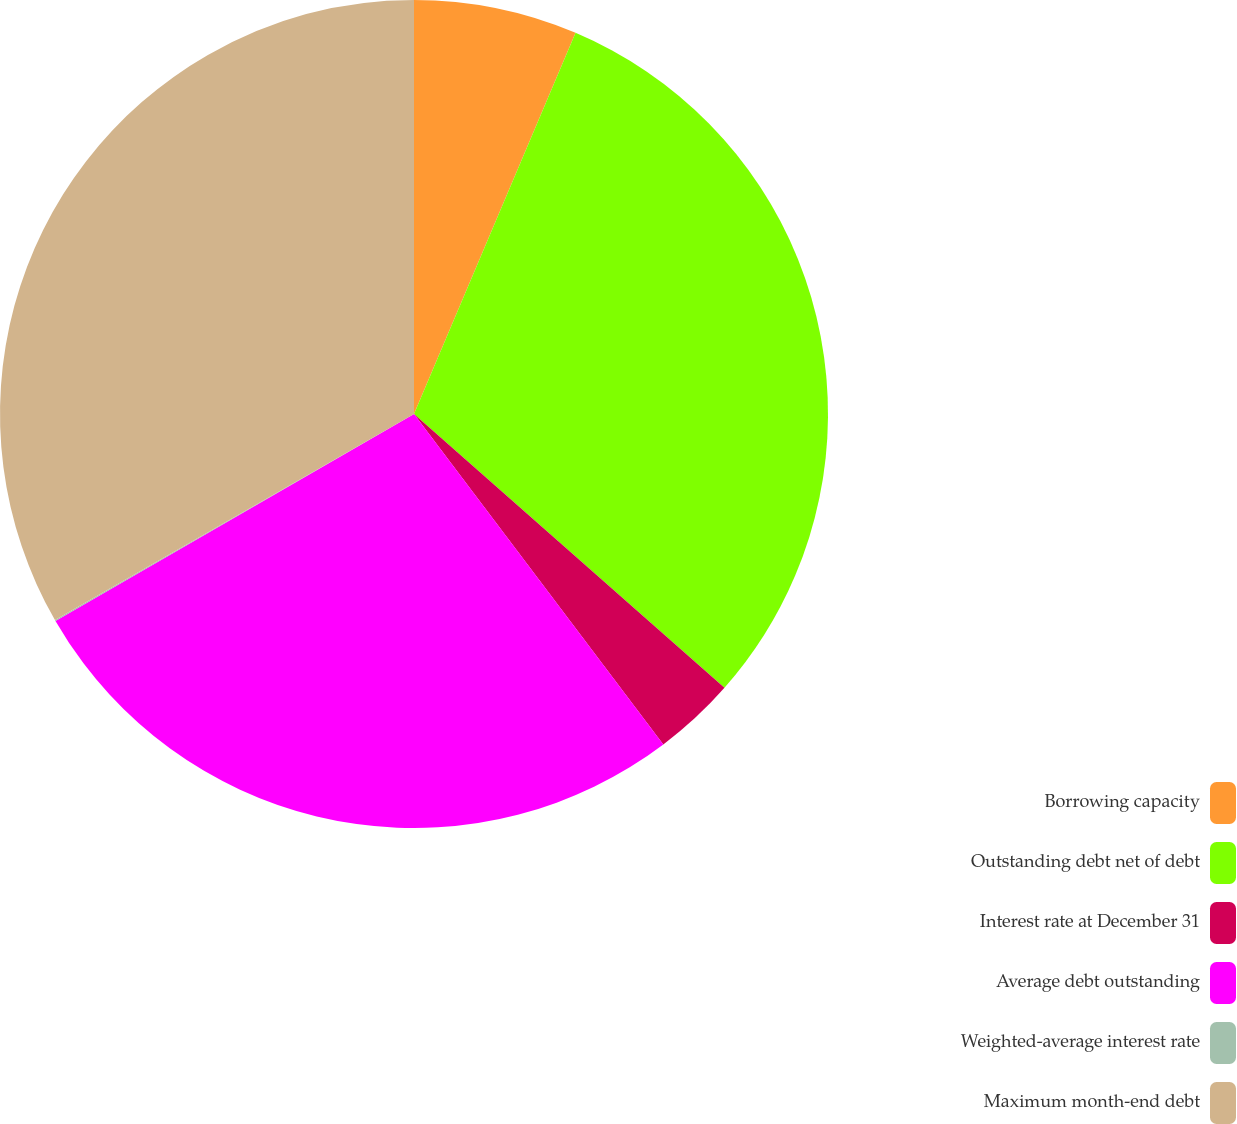Convert chart to OTSL. <chart><loc_0><loc_0><loc_500><loc_500><pie_chart><fcel>Borrowing capacity<fcel>Outstanding debt net of debt<fcel>Interest rate at December 31<fcel>Average debt outstanding<fcel>Weighted-average interest rate<fcel>Maximum month-end debt<nl><fcel>6.38%<fcel>30.12%<fcel>3.21%<fcel>26.95%<fcel>0.04%<fcel>33.29%<nl></chart> 